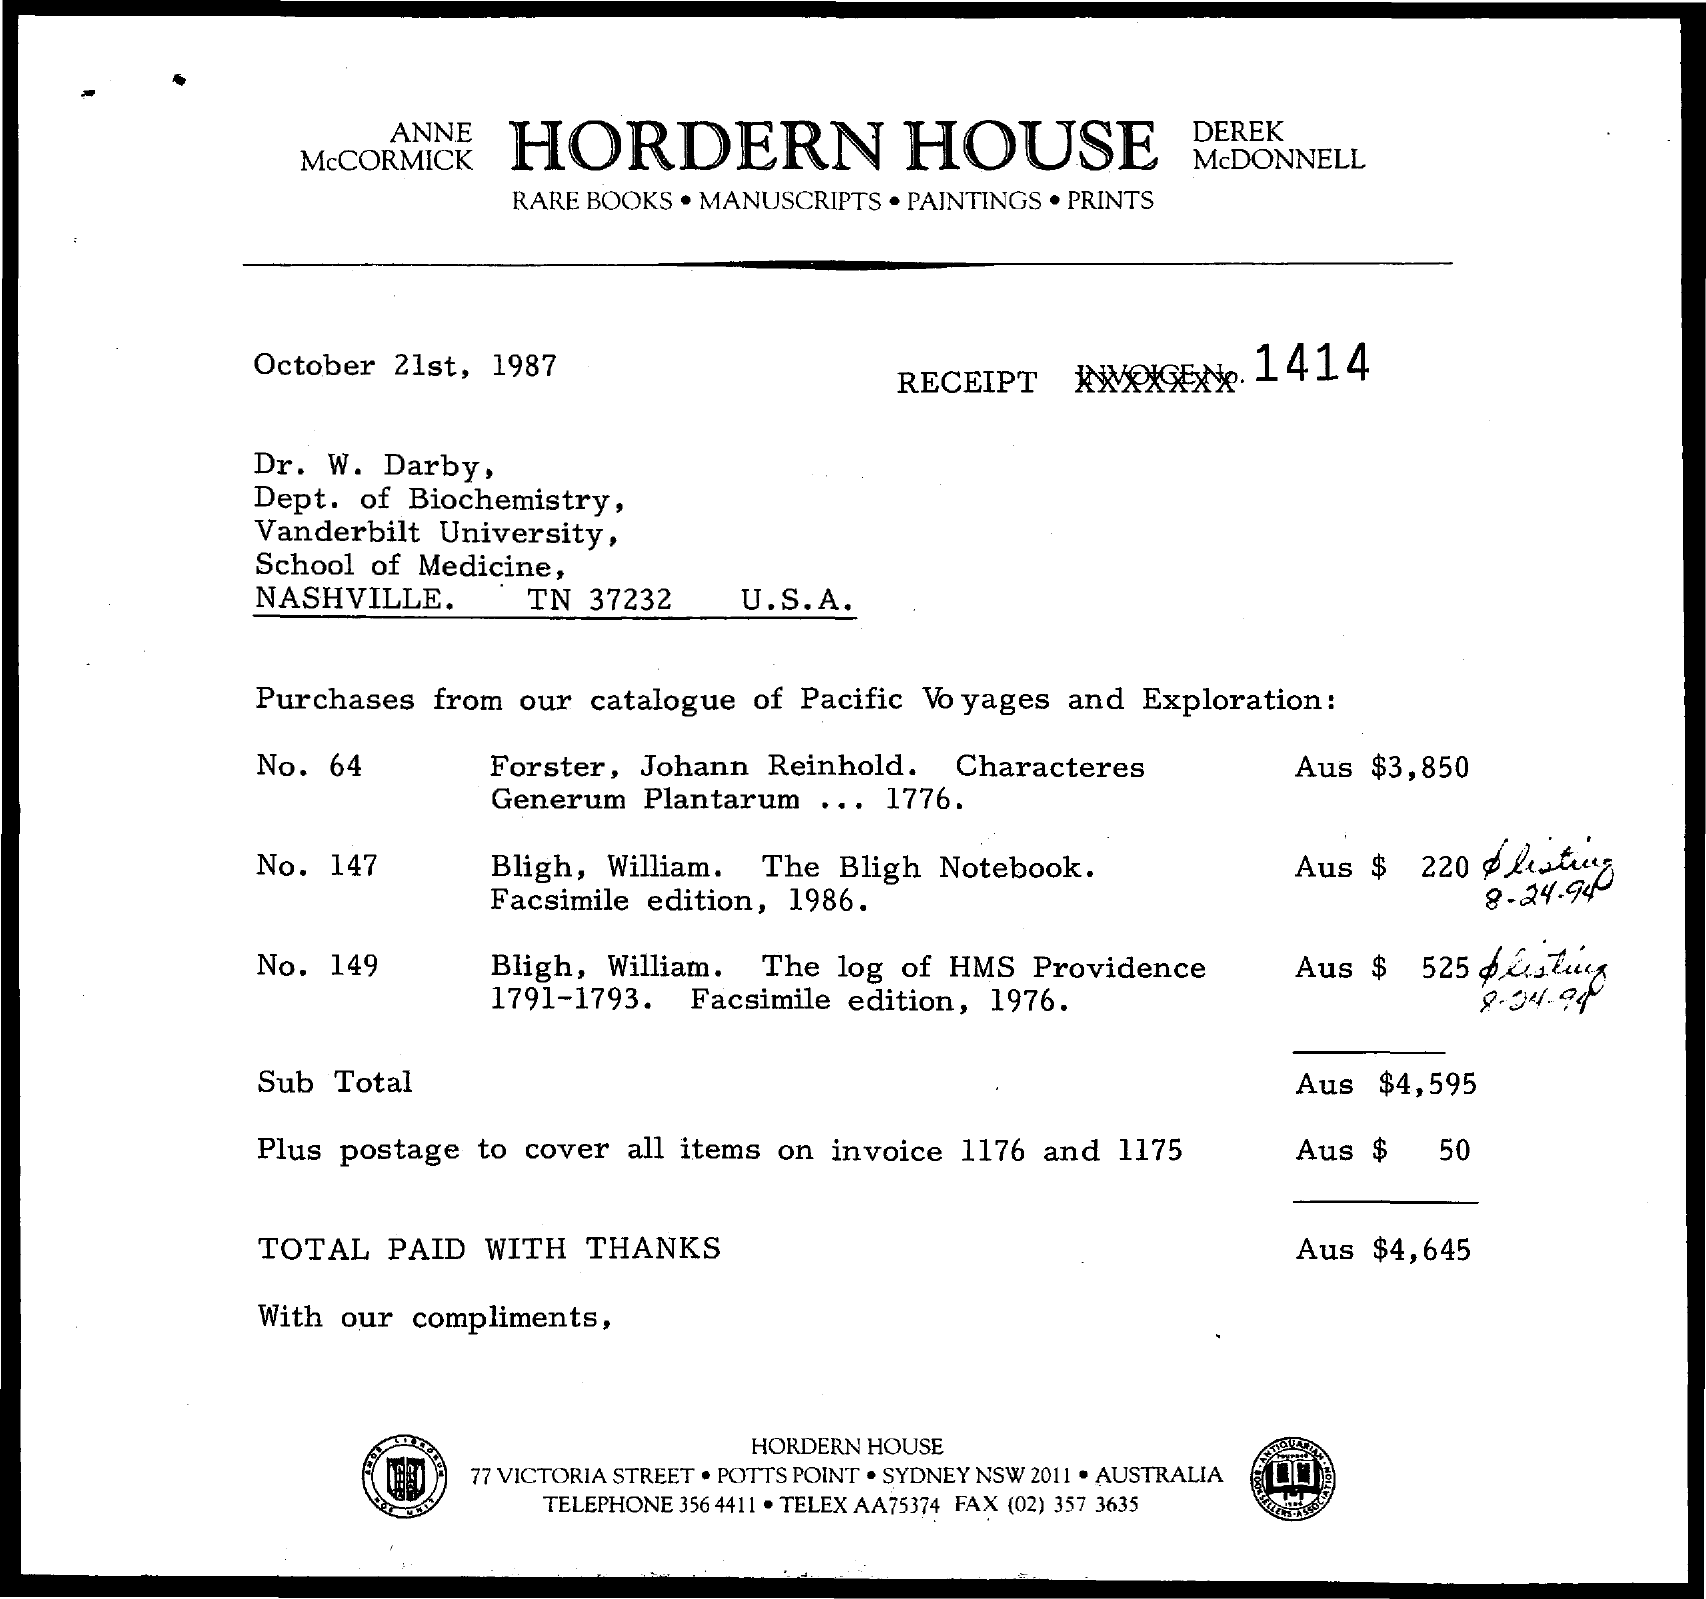What is the receipt invoice no.?
Provide a succinct answer. 1414. To which department does Dr. W . Darby belong to?
Provide a succinct answer. Dept. of Biochemistry. What is the telephone number of hordern house?
Keep it short and to the point. 356 4411. What is the telex no. of hordern house?
Your answer should be very brief. AA75374. What is the fax no. of hordern house?
Give a very brief answer. (02) 357 3635. What is the total amount ?
Your answer should be very brief. AUS $4,645. What is the amount charged for postage to cover all items on invoice 1176 and 1175?
Give a very brief answer. Aus $50. 